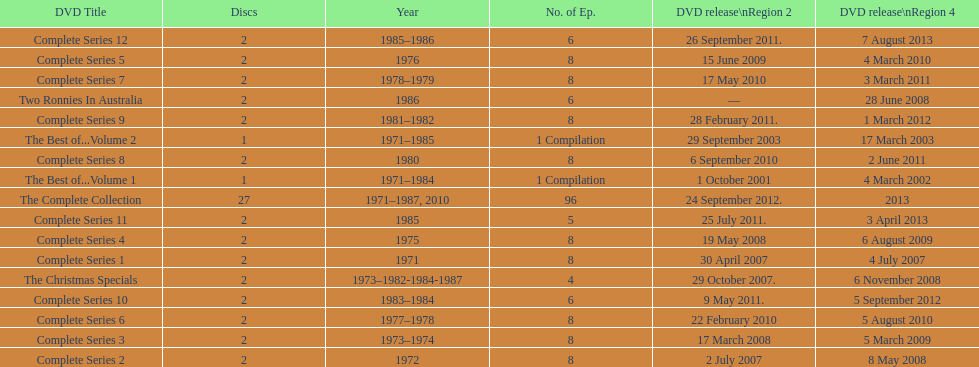Can you give me this table as a dict? {'header': ['DVD Title', 'Discs', 'Year', 'No. of Ep.', 'DVD release\\nRegion 2', 'DVD release\\nRegion 4'], 'rows': [['Complete Series 12', '2', '1985–1986', '6', '26 September 2011.', '7 August 2013'], ['Complete Series 5', '2', '1976', '8', '15 June 2009', '4 March 2010'], ['Complete Series 7', '2', '1978–1979', '8', '17 May 2010', '3 March 2011'], ['Two Ronnies In Australia', '2', '1986', '6', '—', '28 June 2008'], ['Complete Series 9', '2', '1981–1982', '8', '28 February 2011.', '1 March 2012'], ['The Best of...Volume 2', '1', '1971–1985', '1 Compilation', '29 September 2003', '17 March 2003'], ['Complete Series 8', '2', '1980', '8', '6 September 2010', '2 June 2011'], ['The Best of...Volume 1', '1', '1971–1984', '1 Compilation', '1 October 2001', '4 March 2002'], ['The Complete Collection', '27', '1971–1987, 2010', '96', '24 September 2012.', '2013'], ['Complete Series 11', '2', '1985', '5', '25 July 2011.', '3 April 2013'], ['Complete Series 4', '2', '1975', '8', '19 May 2008', '6 August 2009'], ['Complete Series 1', '2', '1971', '8', '30 April 2007', '4 July 2007'], ['The Christmas Specials', '2', '1973–1982-1984-1987', '4', '29 October 2007.', '6 November 2008'], ['Complete Series 10', '2', '1983–1984', '6', '9 May 2011.', '5 September 2012'], ['Complete Series 6', '2', '1977–1978', '8', '22 February 2010', '5 August 2010'], ['Complete Series 3', '2', '1973–1974', '8', '17 March 2008', '5 March 2009'], ['Complete Series 2', '2', '1972', '8', '2 July 2007', '8 May 2008']]} Total number of episodes released in region 2 in 2007 20. 